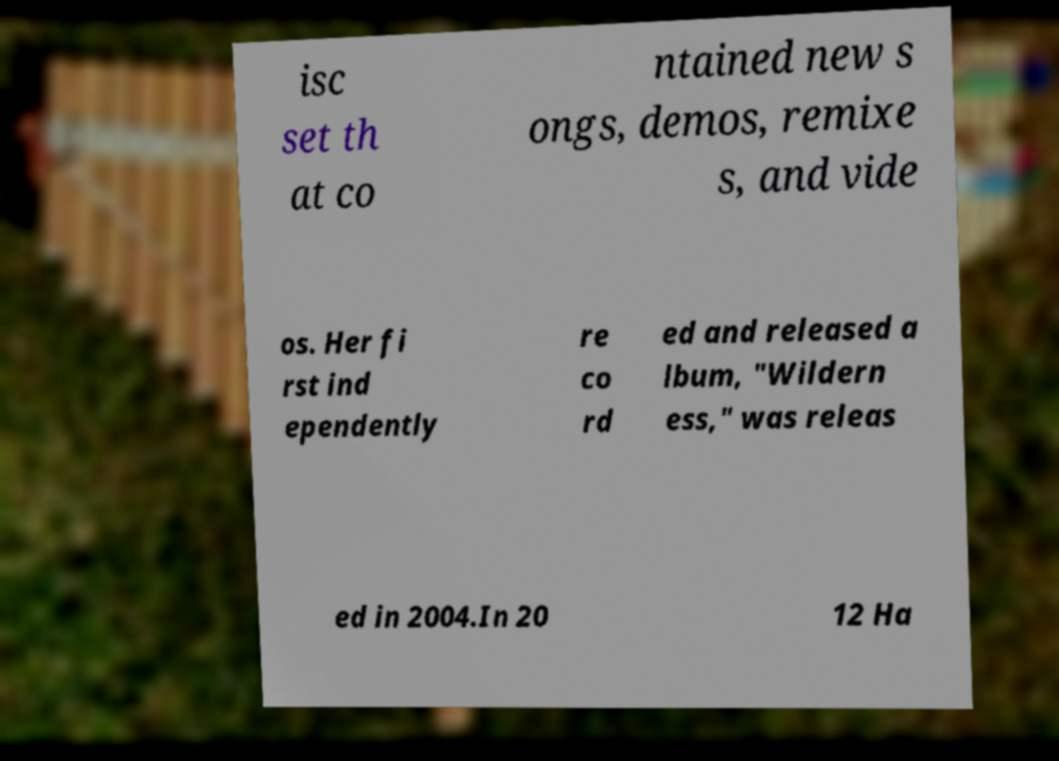What messages or text are displayed in this image? I need them in a readable, typed format. isc set th at co ntained new s ongs, demos, remixe s, and vide os. Her fi rst ind ependently re co rd ed and released a lbum, "Wildern ess," was releas ed in 2004.In 20 12 Ha 